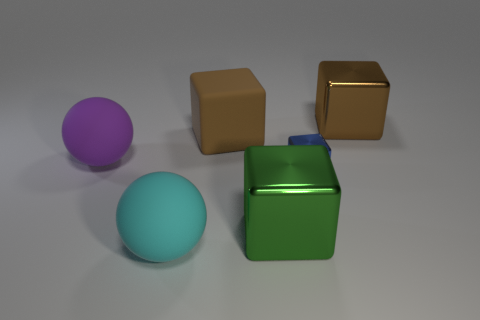Add 1 blue cubes. How many objects exist? 7 Subtract all spheres. How many objects are left? 4 Add 5 big objects. How many big objects are left? 10 Add 1 brown matte blocks. How many brown matte blocks exist? 2 Subtract 0 yellow spheres. How many objects are left? 6 Subtract all large blue shiny things. Subtract all brown cubes. How many objects are left? 4 